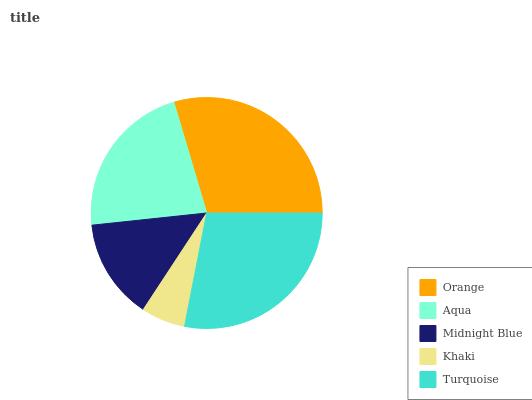Is Khaki the minimum?
Answer yes or no. Yes. Is Orange the maximum?
Answer yes or no. Yes. Is Aqua the minimum?
Answer yes or no. No. Is Aqua the maximum?
Answer yes or no. No. Is Orange greater than Aqua?
Answer yes or no. Yes. Is Aqua less than Orange?
Answer yes or no. Yes. Is Aqua greater than Orange?
Answer yes or no. No. Is Orange less than Aqua?
Answer yes or no. No. Is Aqua the high median?
Answer yes or no. Yes. Is Aqua the low median?
Answer yes or no. Yes. Is Midnight Blue the high median?
Answer yes or no. No. Is Turquoise the low median?
Answer yes or no. No. 